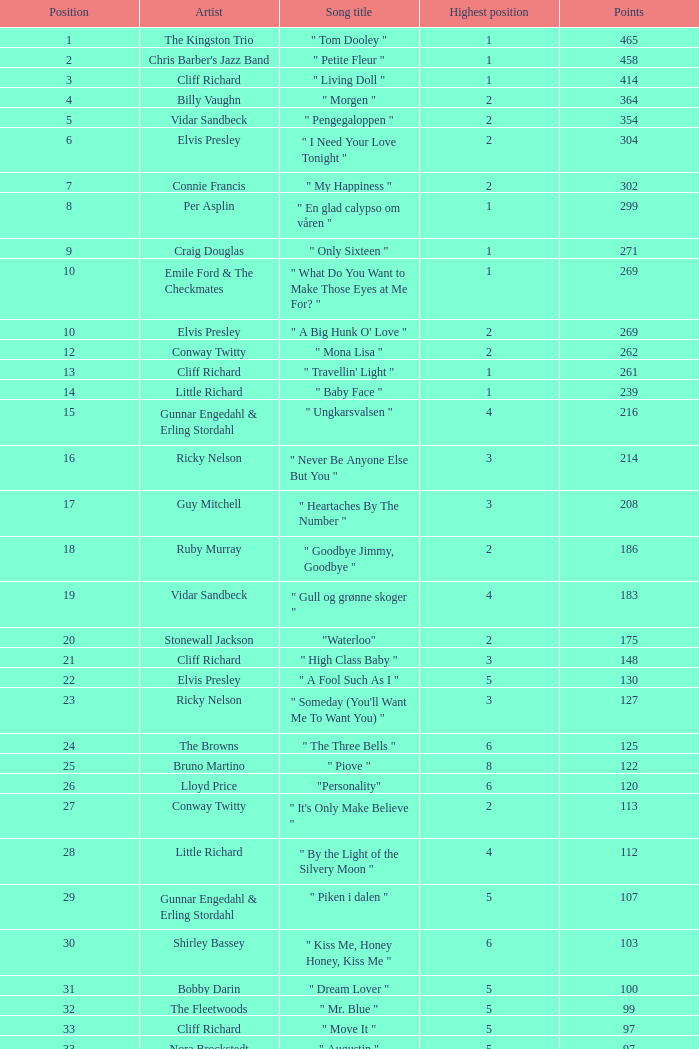What is the name of the track sung by billy vaughn? " Morgen ". 